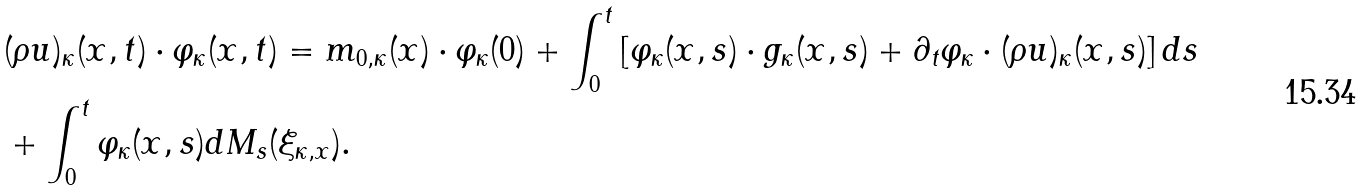Convert formula to latex. <formula><loc_0><loc_0><loc_500><loc_500>& ( \rho u ) _ { \kappa } ( x , t ) \cdot \varphi _ { \kappa } ( x , t ) = m _ { 0 , \kappa } ( x ) \cdot \varphi _ { \kappa } ( 0 ) + \int _ { 0 } ^ { t } \left [ \varphi _ { \kappa } ( x , s ) \cdot g _ { \kappa } ( x , s ) + \partial _ { t } \varphi _ { \kappa } \cdot ( \rho u ) _ { \kappa } ( x , s ) \right ] d s \\ & + \int _ { 0 } ^ { t } \varphi _ { \kappa } ( x , s ) d M _ { s } ( \xi _ { \kappa , x } ) .</formula> 